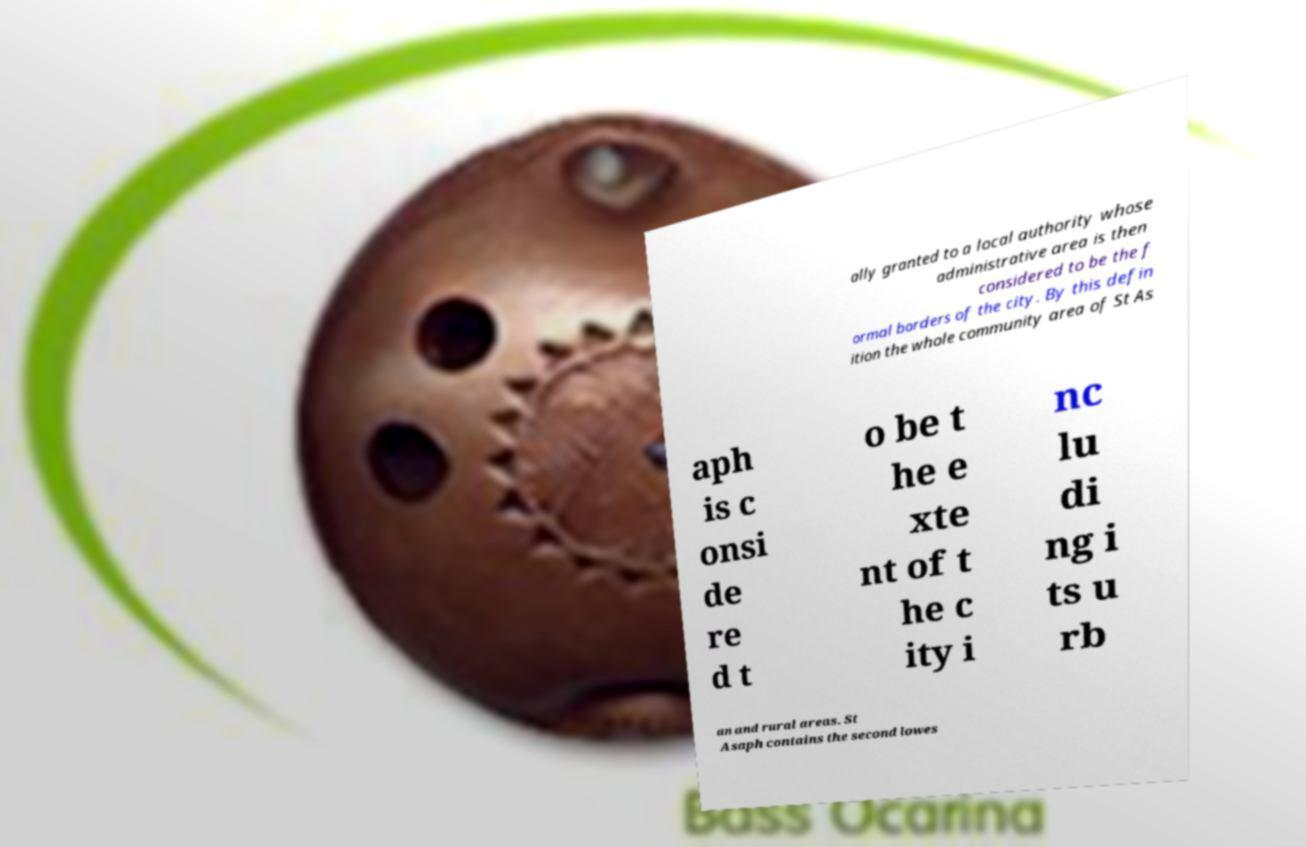What messages or text are displayed in this image? I need them in a readable, typed format. ally granted to a local authority whose administrative area is then considered to be the f ormal borders of the city. By this defin ition the whole community area of St As aph is c onsi de re d t o be t he e xte nt of t he c ity i nc lu di ng i ts u rb an and rural areas. St Asaph contains the second lowes 